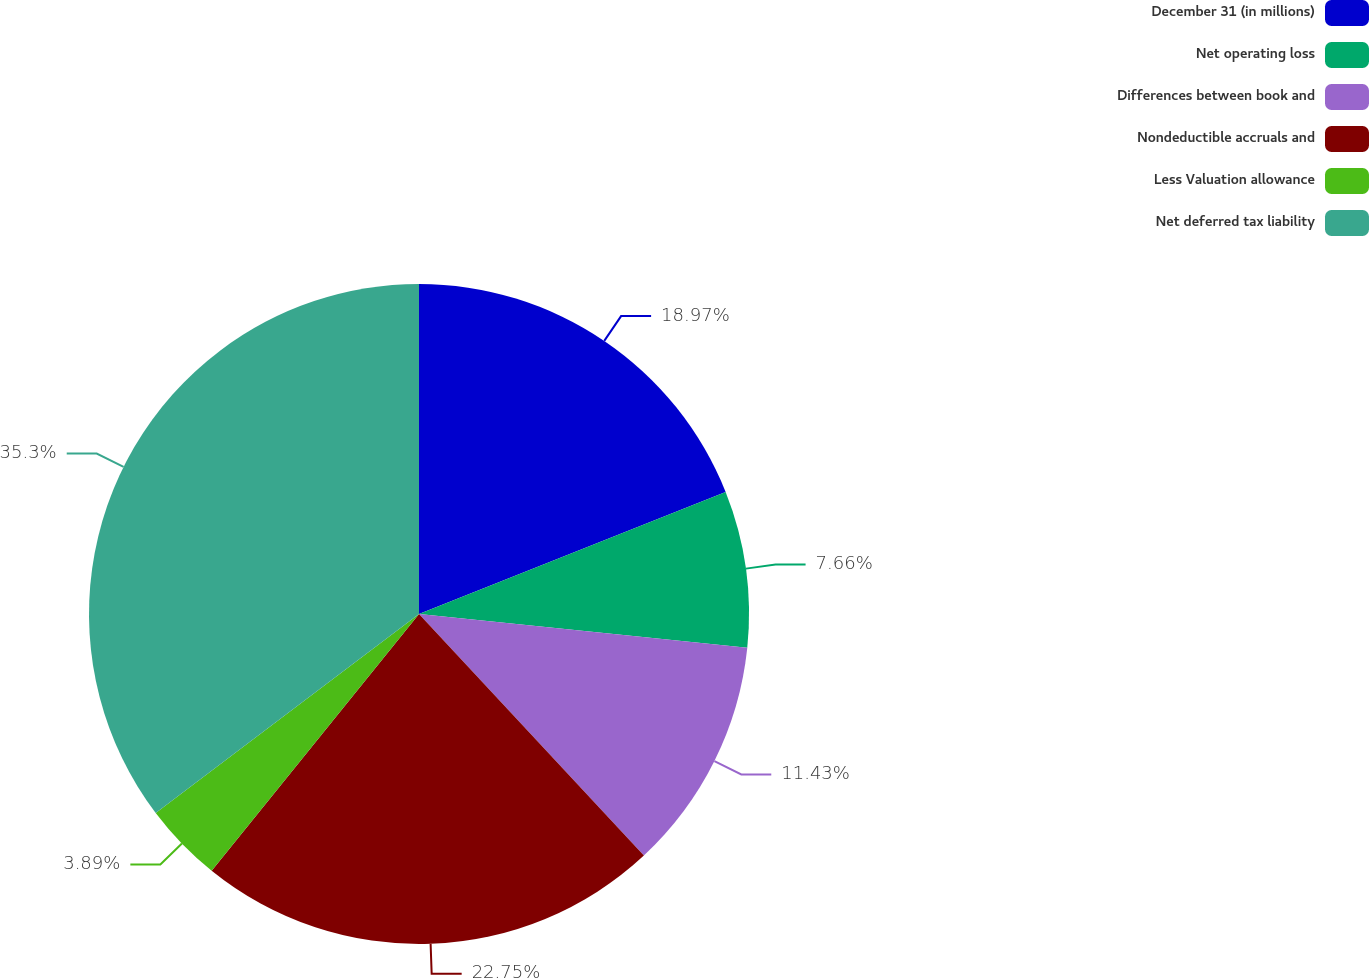<chart> <loc_0><loc_0><loc_500><loc_500><pie_chart><fcel>December 31 (in millions)<fcel>Net operating loss<fcel>Differences between book and<fcel>Nondeductible accruals and<fcel>Less Valuation allowance<fcel>Net deferred tax liability<nl><fcel>18.97%<fcel>7.66%<fcel>11.43%<fcel>22.74%<fcel>3.89%<fcel>35.29%<nl></chart> 